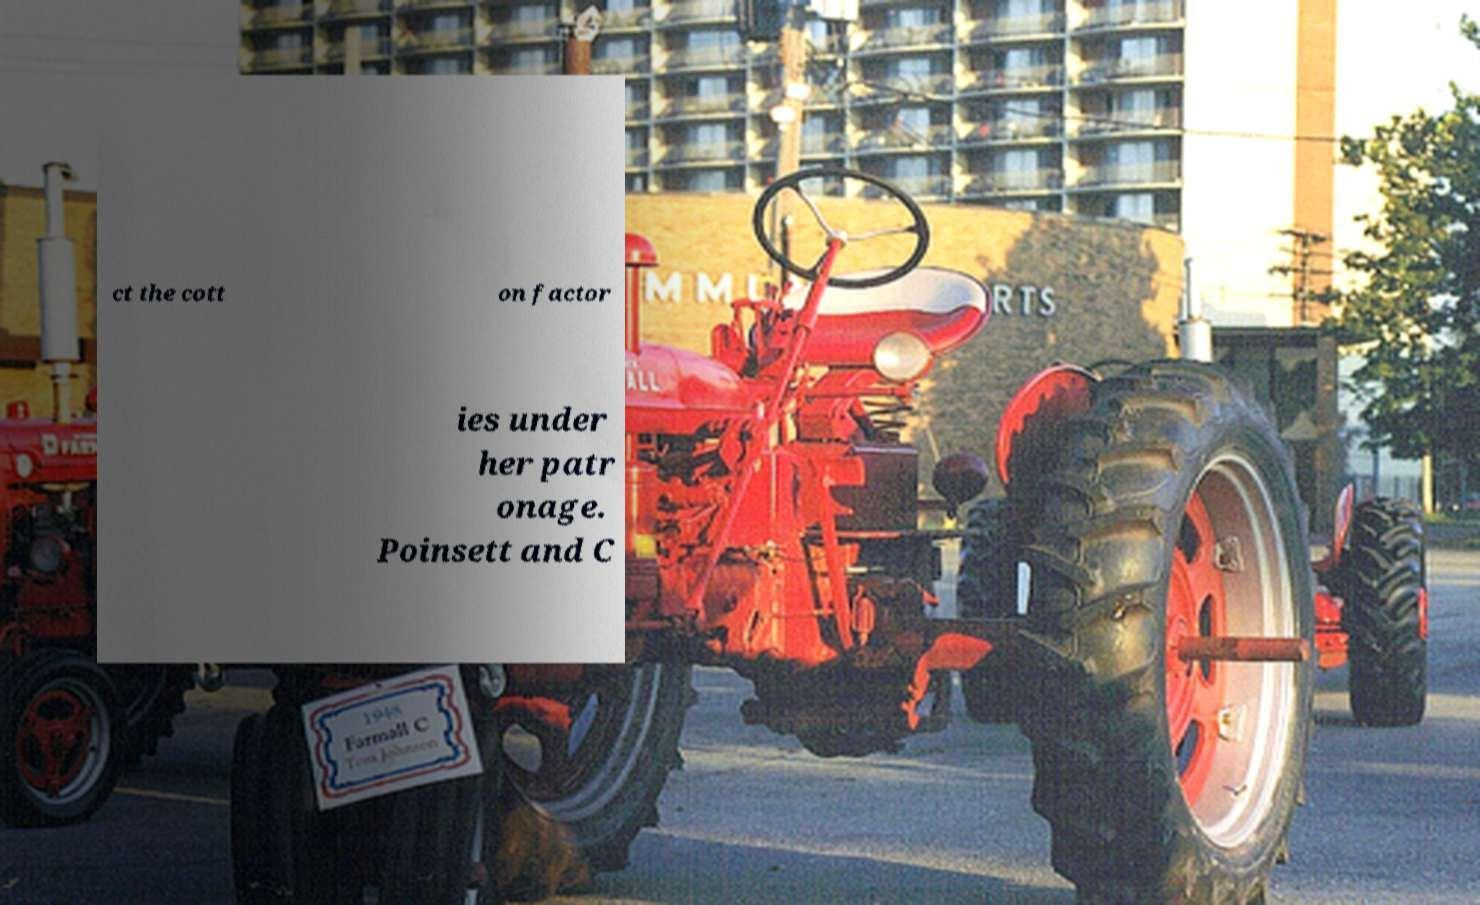Can you read and provide the text displayed in the image?This photo seems to have some interesting text. Can you extract and type it out for me? ct the cott on factor ies under her patr onage. Poinsett and C 